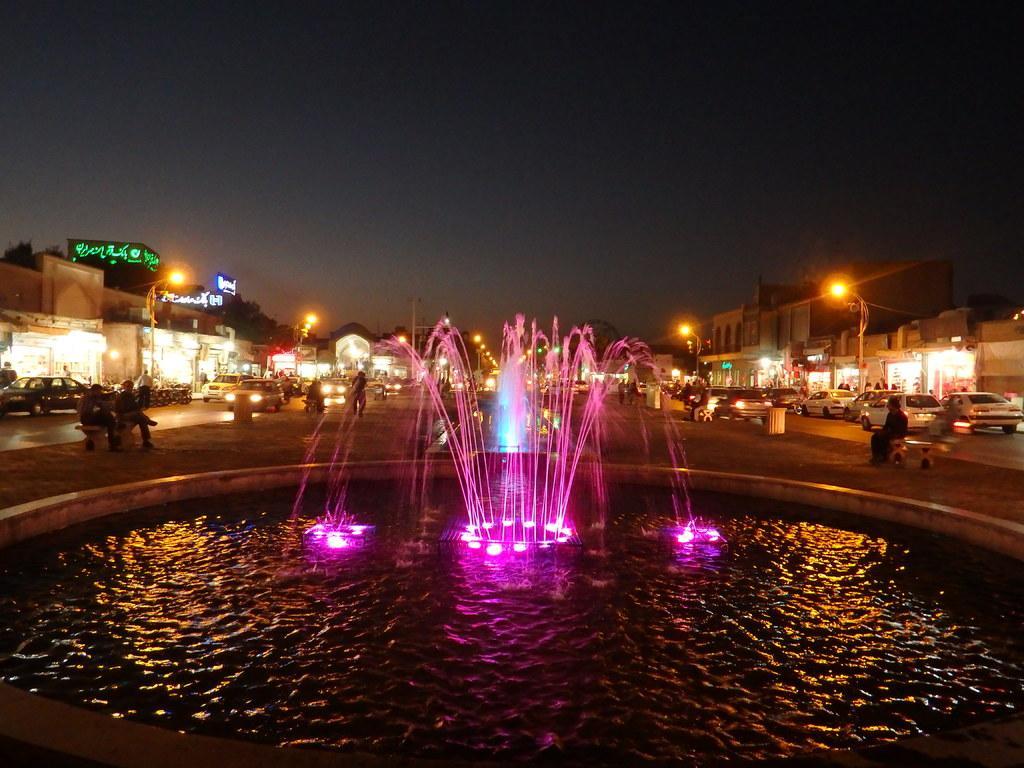Please provide a concise description of this image. In this image I can see a fountain and few lights. Background I can see few people some are standing and some are sitting, few vehicles, stalls, light poles and sky. 